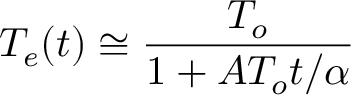Convert formula to latex. <formula><loc_0><loc_0><loc_500><loc_500>T _ { e } ( t ) \cong \frac { T _ { o } } { 1 + A T _ { o } t / \alpha }</formula> 